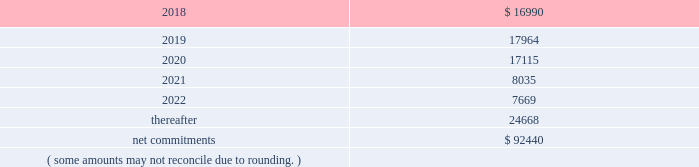On november 18 , 2014 , the company entered into a collateralized reinsurance agreement with kilimanjaro to provide the company with catastrophe reinsurance coverage .
This agreement is a multi-year reinsurance contract which covers specified earthquake events .
The agreement provides up to $ 500000 thousand of reinsurance coverage from earthquakes in the united states , puerto rico and canada .
On december 1 , 2015 the company entered into two collateralized reinsurance agreements with kilimanjaro re to provide the company with catastrophe reinsurance coverage .
These agreements are multi-year reinsurance contracts which cover named storm and earthquake events .
The first agreement provides up to $ 300000 thousand of reinsurance coverage from named storms and earthquakes in the united states , puerto rico and canada .
The second agreement provides up to $ 325000 thousand of reinsurance coverage from named storms and earthquakes in the united states , puerto rico and canada .
On april 13 , 2017 the company entered into six collateralized reinsurance agreements with kilimanjaro to provide the company with annual aggregate catastrophe reinsurance coverage .
The initial three agreements are four year reinsurance contracts which cover named storm and earthquake events .
These agreements provide up to $ 225000 thousand , $ 400000 thousand and $ 325000 thousand , respectively , of annual aggregate reinsurance coverage from named storms and earthquakes in the united states , puerto rico and canada .
The subsequent three agreements are five year reinsurance contracts which cover named storm and earthquake events .
These agreements provide up to $ 50000 thousand , $ 75000 thousand and $ 175000 thousand , respectively , of annual aggregate reinsurance coverage from named storms and earthquakes in the united states , puerto rico and canada .
Recoveries under these collateralized reinsurance agreements with kilimanjaro are primarily dependent on estimated industry level insured losses from covered events , as well as , the geographic location of the events .
The estimated industry level of insured losses is obtained from published estimates by an independent recognized authority on insured property losses .
As of december 31 , 2017 , none of the published insured loss estimates for the 2017 catastrophe events have exceeded the single event retentions under the terms of the agreements that would result in a recovery .
In addition , the aggregation of the to-date published insured loss estimates for the 2017 covered events have not exceeded the aggregated retentions for recovery .
However , if the published estimates for insured losses for the covered 2017 events increase , the aggregate losses may exceed the aggregate event retentions under the agreements , resulting in a recovery .
Kilimanjaro has financed the various property catastrophe reinsurance coverages by issuing catastrophe bonds to unrelated , external investors .
On april 24 , 2014 , kilimanjaro issued $ 450000 thousand of notes ( 201cseries 2014-1 notes 201d ) .
On november 18 , 2014 , kilimanjaro issued $ 500000 thousand of notes ( 201cseries 2014-2 notes 201d ) .
On december 1 , 2015 , kilimanjaro issued $ 625000 thousand of notes ( 201cseries 2015-1 notes ) .
On april 13 , 2017 , kilimanjaro issued $ 950000 thousand of notes ( 201cseries 2017-1 notes ) and $ 300000 thousand of notes ( 201cseries 2017-2 notes ) .
The proceeds from the issuance of the notes listed above are held in reinsurance trust throughout the duration of the applicable reinsurance agreements and invested solely in us government money market funds with a rating of at least 201caaam 201d by standard & poor 2019s .
Operating lease agreements the future minimum rental commitments , exclusive of cost escalation clauses , at december 31 , 2017 , for all of the company 2019s operating leases with remaining non-cancelable terms in excess of one year are as follows : ( dollars in thousands ) .

What is the total value of notes issued by kilimanjaro from 2014 to 2017 , in thousands? 
Computations: ((((450000 + 500000) + 625000) + (450000 + 500000)) + 300000)
Answer: 2825000.0. 